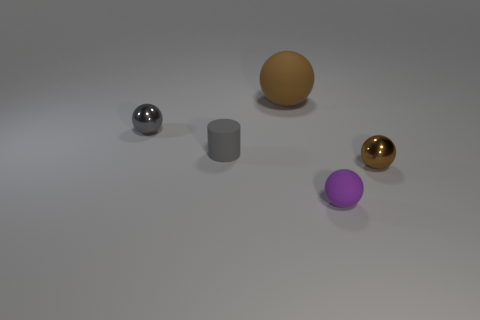Add 5 purple things. How many objects exist? 10 Subtract all cylinders. How many objects are left? 4 Subtract 0 green spheres. How many objects are left? 5 Subtract all brown rubber objects. Subtract all brown metal cylinders. How many objects are left? 4 Add 2 small matte cylinders. How many small matte cylinders are left? 3 Add 3 purple shiny cubes. How many purple shiny cubes exist? 3 